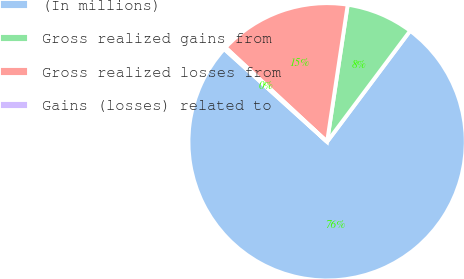Convert chart. <chart><loc_0><loc_0><loc_500><loc_500><pie_chart><fcel>(In millions)<fcel>Gross realized gains from<fcel>Gross realized losses from<fcel>Gains (losses) related to<nl><fcel>76.45%<fcel>7.85%<fcel>15.47%<fcel>0.23%<nl></chart> 